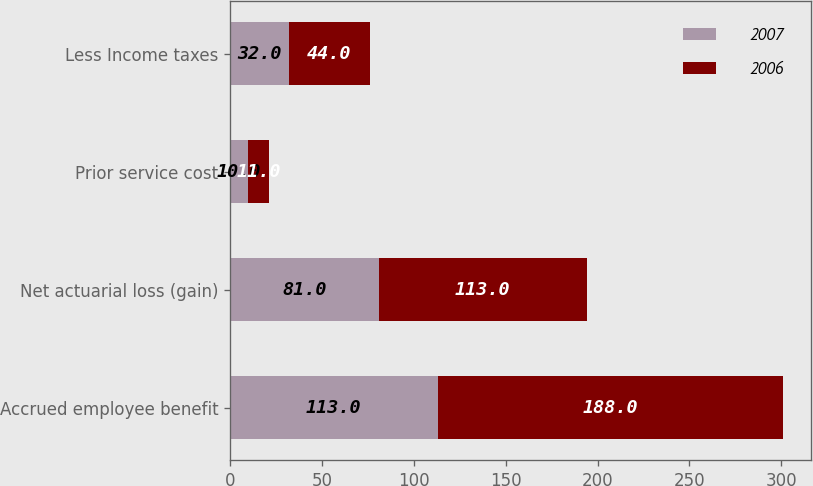Convert chart to OTSL. <chart><loc_0><loc_0><loc_500><loc_500><stacked_bar_chart><ecel><fcel>Accrued employee benefit<fcel>Net actuarial loss (gain)<fcel>Prior service cost<fcel>Less Income taxes<nl><fcel>2007<fcel>113<fcel>81<fcel>10<fcel>32<nl><fcel>2006<fcel>188<fcel>113<fcel>11<fcel>44<nl></chart> 